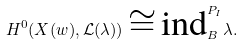<formula> <loc_0><loc_0><loc_500><loc_500>H ^ { 0 } ( X ( w ) , { \mathcal { L } } ( \lambda ) ) \cong \text {ind} _ { B } ^ { P _ { I } } \lambda .</formula> 